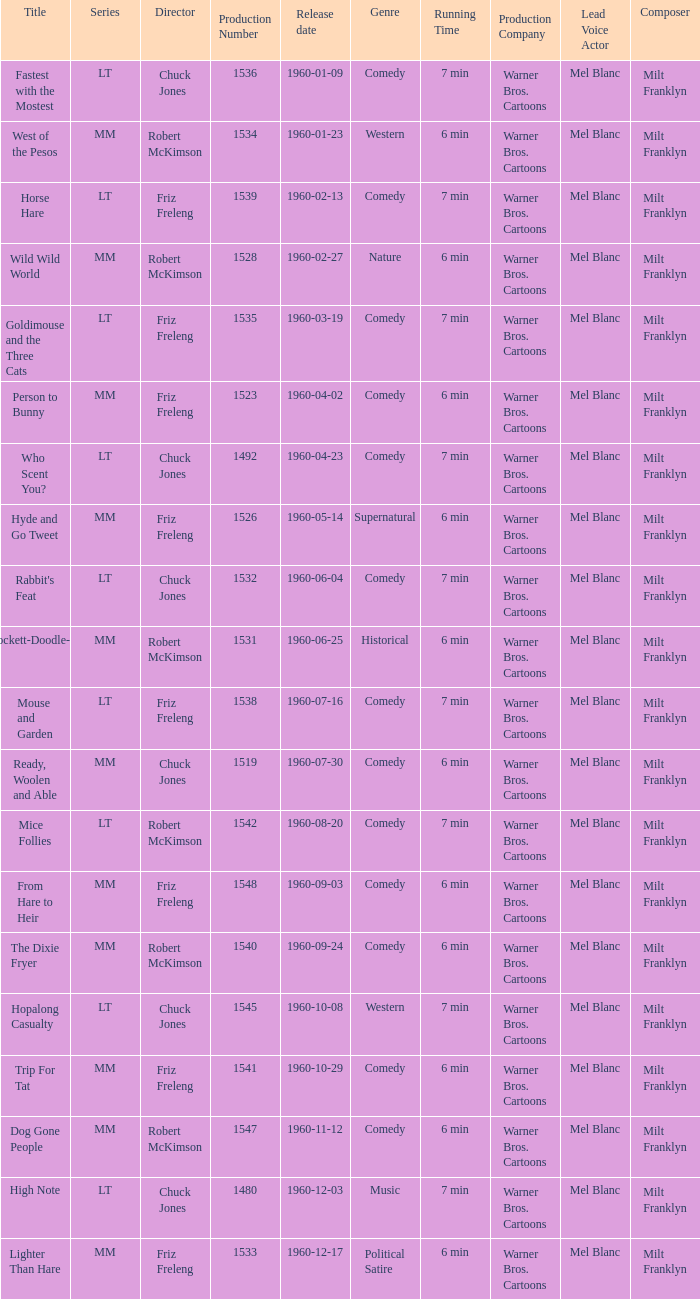What is the Series number of the episode with a production number of 1547? MM. 